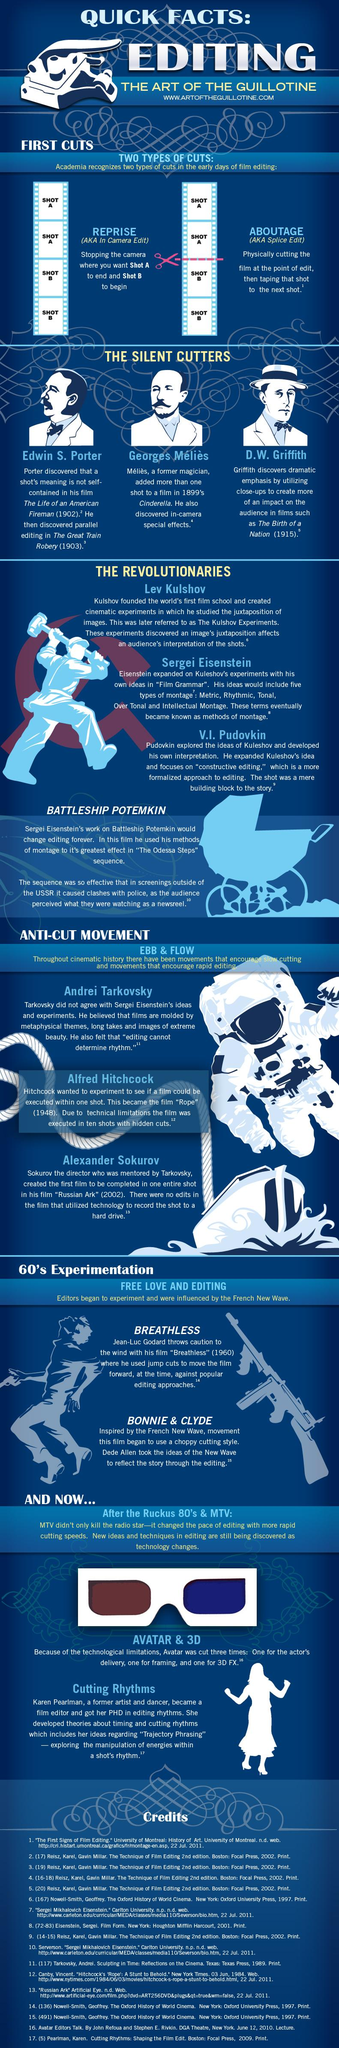Give some essential details in this illustration. Breathless is a film that utilizes jump cuts to create a downward shift in the narrative. The film that showcases the use of parallel editing is The Great Train Robbery. There are two types of movie editing cuts: Reprise and Aboutage. In the film "Cinderella," more than a single shot includes a specific element. The second cut of the movie "Avatar" was done for framing purposes. 